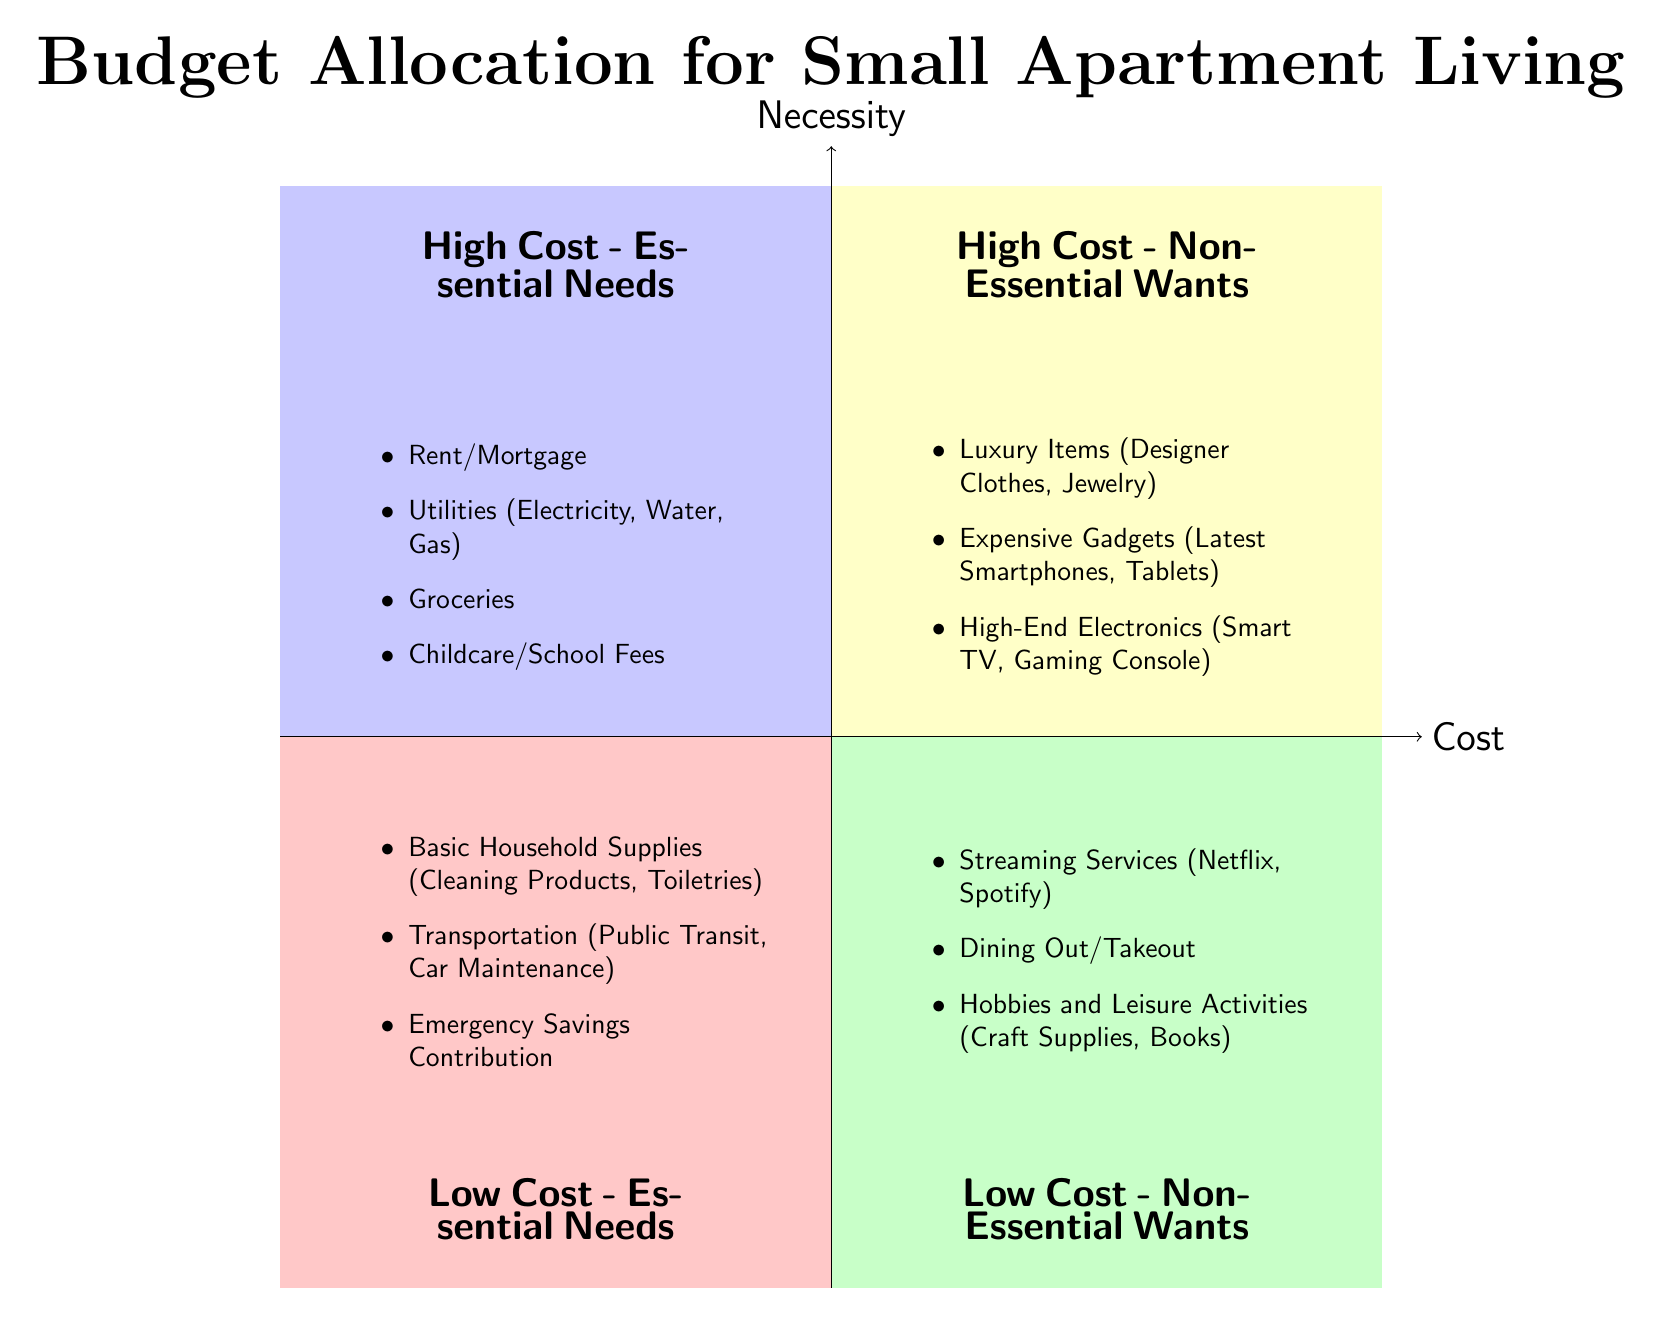What items are listed under High Cost - Essential Needs? The quadrant titled "High Cost - Essential Needs" contains four specific items: Rent/Mortgage, Utilities, Groceries, and Childcare/School Fees.
Answer: Rent/Mortgage, Utilities (Electricity, Water, Gas), Groceries, Childcare/School Fees How many items are listed under Low Cost - Non-Essential Wants? The quadrant "Low Cost - Non-Essential Wants" includes three items: Streaming Services, Dining Out/Takeout, and Hobbies and Leisure Activities. The count of items is therefore three.
Answer: 3 Which quadrant contains Luxury Items? Luxury Items are listed under the "High Cost - Non-Essential Wants" quadrant. This can be identified as it is explicitly grouped in that category.
Answer: High Cost - Non-Essential Wants Are there any items that fit both Low Cost and Essential Needs categories? Yes, items listed under "Low Cost - Essential Needs" include Basic Household Supplies, Transportation, and Emergency Savings Contribution, confirming that these are essential and low cost.
Answer: Yes What is the relationship between High Cost - Non-Essential Wants and Low Cost - Essential Needs? High Cost - Non-Essential Wants contains items that are discretionary in nature such as luxury or expensive items, while Low Cost - Essential Needs includes essential items that are affordable. This indicates that one's budget should be allocated carefully to prioritize essentials over non-essentials.
Answer: High Cost - Non-Essential Wants contains discretionary items; Low Cost - Essential Needs contains affordable essentials How many quadrants are represented in this diagram? The diagram clearly displays four quadrants: High Cost - Essential Needs, High Cost - Non-Essential Wants, Low Cost - Essential Needs, and Low Cost - Non-Essential Wants. Counting these gives the total of four quadrants.
Answer: 4 